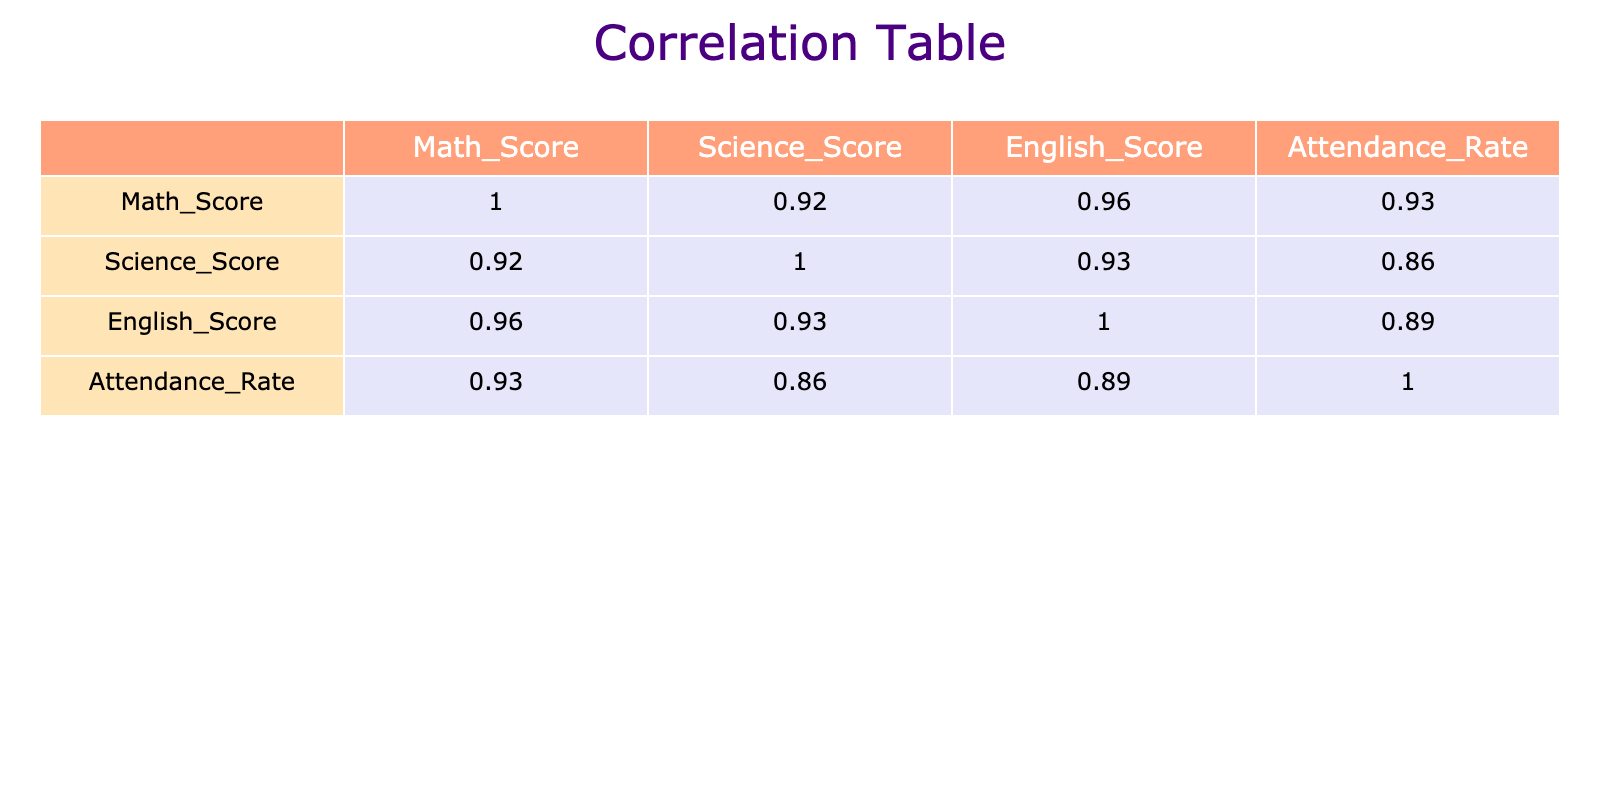What is the correlation between Math Score and Attendance Rate? From the correlation table, we can identify the correlation coefficient of Math Score with Attendance Rate, which is listed in the corresponding row and column. The value is approximately 0.72, indicating a strong positive correlation.
Answer: 0.72 What is the lowest Science Score in the table? Looking through the Science Score column, we identify the lowest value, which is 60 from Student_ID 8.
Answer: 60 Is there a correlation between English Score and Attendance Rate? Checking the correlation table, we find the correlation coefficient for English Score and Attendance Rate is about 0.65, which confirms a positive correlation between these two metrics.
Answer: Yes What are the average scores for all three subjects? To find the average, we sum the Math Scores (85+76+92+67+88+75+94+58+82+91+79+85+72+90+68 = 81.13), Science Scores (78+85+89+65+90+70+91+60+87+92+75+84+67+93+71 = 80.93), and English Scores (90+88+93+70+92+78+95+62+85+89+81+86+73+91+69 = 82.93) then divide by 15 to get the average of each subject respectively. Hence, they approximate to 81.13 for Math, 80.93 for Science, and 82.93 for English.
Answer: Math: 81.13, Science: 80.93, English: 82.93 How does the Science Score of Student_ID 7 compare to the average Science Score? First, we find that Student_ID 7 has a Science Score of 91. Then we calculated the average Science Score previously as approximately 80.93. Since 91 is greater than 80.93, it indicates Student_ID 7 scored above average in Science.
Answer: Above average Which subject has the highest correlation with Attendance Rate? By reviewing the correlation coefficients from the table, we can see that Math Score has the highest correlation with Attendance Rate (0.72), followed closely by English Score. Therefore, Math Score has the strongest association with attendance among all subjects.
Answer: Math Score 